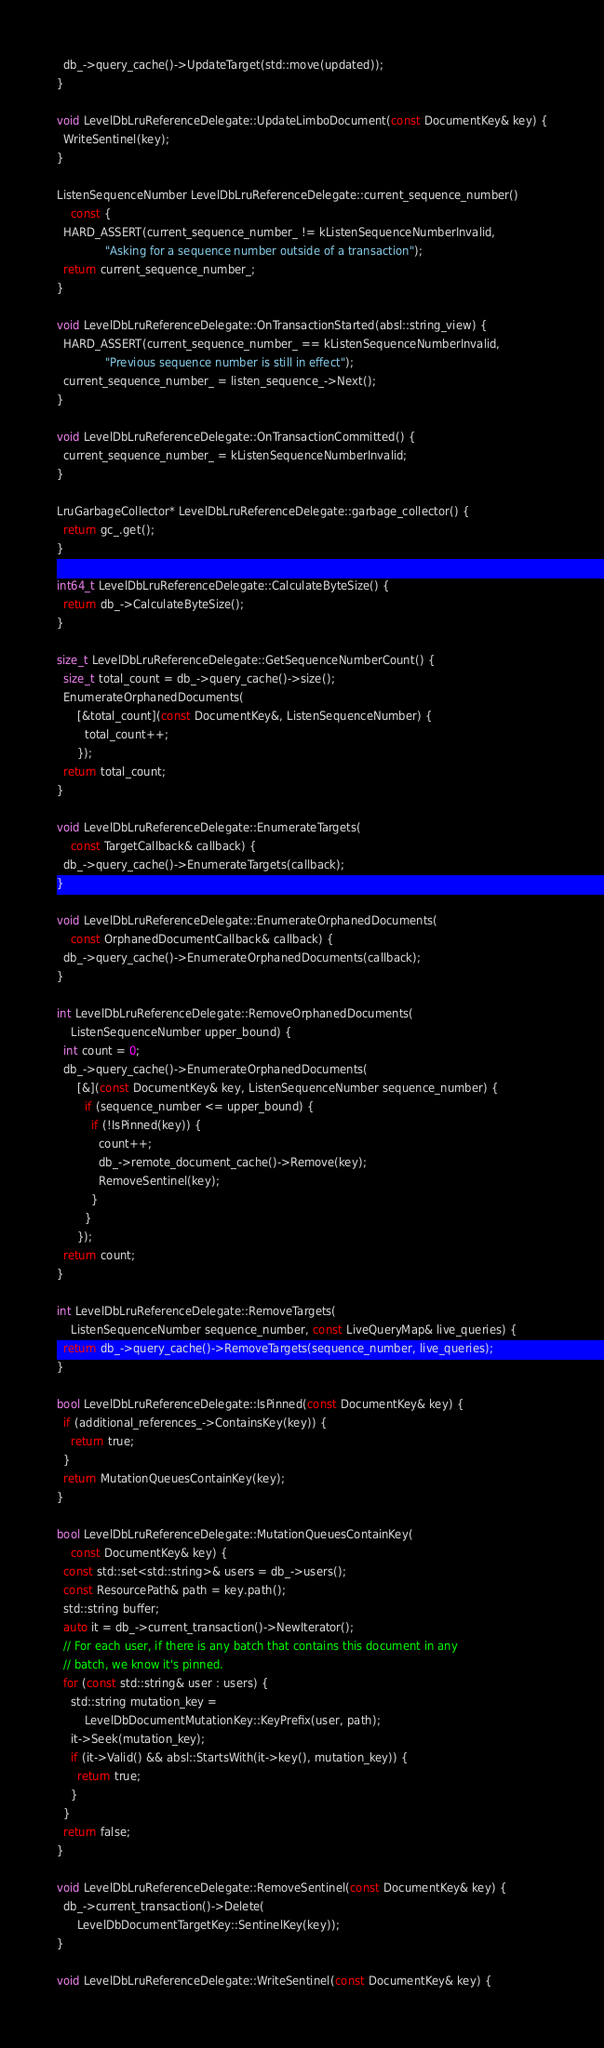<code> <loc_0><loc_0><loc_500><loc_500><_ObjectiveC_>  db_->query_cache()->UpdateTarget(std::move(updated));
}

void LevelDbLruReferenceDelegate::UpdateLimboDocument(const DocumentKey& key) {
  WriteSentinel(key);
}

ListenSequenceNumber LevelDbLruReferenceDelegate::current_sequence_number()
    const {
  HARD_ASSERT(current_sequence_number_ != kListenSequenceNumberInvalid,
              "Asking for a sequence number outside of a transaction");
  return current_sequence_number_;
}

void LevelDbLruReferenceDelegate::OnTransactionStarted(absl::string_view) {
  HARD_ASSERT(current_sequence_number_ == kListenSequenceNumberInvalid,
              "Previous sequence number is still in effect");
  current_sequence_number_ = listen_sequence_->Next();
}

void LevelDbLruReferenceDelegate::OnTransactionCommitted() {
  current_sequence_number_ = kListenSequenceNumberInvalid;
}

LruGarbageCollector* LevelDbLruReferenceDelegate::garbage_collector() {
  return gc_.get();
}

int64_t LevelDbLruReferenceDelegate::CalculateByteSize() {
  return db_->CalculateByteSize();
}

size_t LevelDbLruReferenceDelegate::GetSequenceNumberCount() {
  size_t total_count = db_->query_cache()->size();
  EnumerateOrphanedDocuments(
      [&total_count](const DocumentKey&, ListenSequenceNumber) {
        total_count++;
      });
  return total_count;
}

void LevelDbLruReferenceDelegate::EnumerateTargets(
    const TargetCallback& callback) {
  db_->query_cache()->EnumerateTargets(callback);
}

void LevelDbLruReferenceDelegate::EnumerateOrphanedDocuments(
    const OrphanedDocumentCallback& callback) {
  db_->query_cache()->EnumerateOrphanedDocuments(callback);
}

int LevelDbLruReferenceDelegate::RemoveOrphanedDocuments(
    ListenSequenceNumber upper_bound) {
  int count = 0;
  db_->query_cache()->EnumerateOrphanedDocuments(
      [&](const DocumentKey& key, ListenSequenceNumber sequence_number) {
        if (sequence_number <= upper_bound) {
          if (!IsPinned(key)) {
            count++;
            db_->remote_document_cache()->Remove(key);
            RemoveSentinel(key);
          }
        }
      });
  return count;
}

int LevelDbLruReferenceDelegate::RemoveTargets(
    ListenSequenceNumber sequence_number, const LiveQueryMap& live_queries) {
  return db_->query_cache()->RemoveTargets(sequence_number, live_queries);
}

bool LevelDbLruReferenceDelegate::IsPinned(const DocumentKey& key) {
  if (additional_references_->ContainsKey(key)) {
    return true;
  }
  return MutationQueuesContainKey(key);
}

bool LevelDbLruReferenceDelegate::MutationQueuesContainKey(
    const DocumentKey& key) {
  const std::set<std::string>& users = db_->users();
  const ResourcePath& path = key.path();
  std::string buffer;
  auto it = db_->current_transaction()->NewIterator();
  // For each user, if there is any batch that contains this document in any
  // batch, we know it's pinned.
  for (const std::string& user : users) {
    std::string mutation_key =
        LevelDbDocumentMutationKey::KeyPrefix(user, path);
    it->Seek(mutation_key);
    if (it->Valid() && absl::StartsWith(it->key(), mutation_key)) {
      return true;
    }
  }
  return false;
}

void LevelDbLruReferenceDelegate::RemoveSentinel(const DocumentKey& key) {
  db_->current_transaction()->Delete(
      LevelDbDocumentTargetKey::SentinelKey(key));
}

void LevelDbLruReferenceDelegate::WriteSentinel(const DocumentKey& key) {</code> 